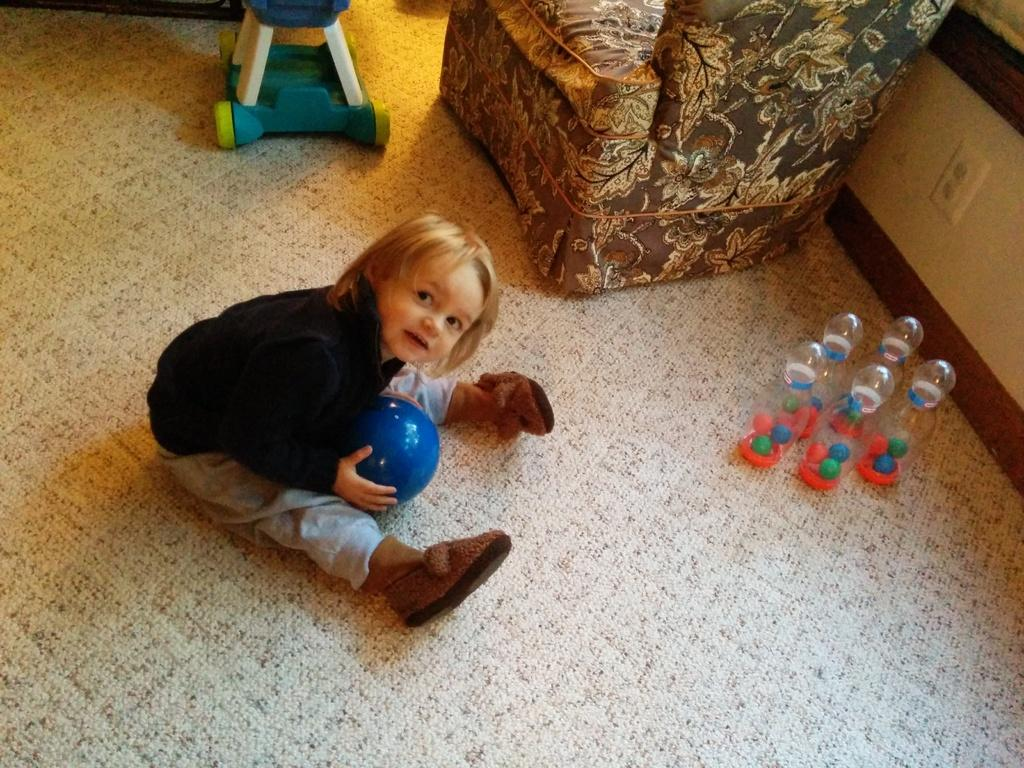What is the kid doing in the image? The kid is sitting in the image. What is the kid holding in the image? The kid is holding a ball. What can be seen on the right side of the image? There are toys on the right side of the image. What is the kid sitting on in the image? There is a chair in the image. What type of gate can be seen in the image? There is no gate present in the image. What historical figure is depicted in the image? The image does not depict any historical figures; it features a kid sitting and holding a ball. 